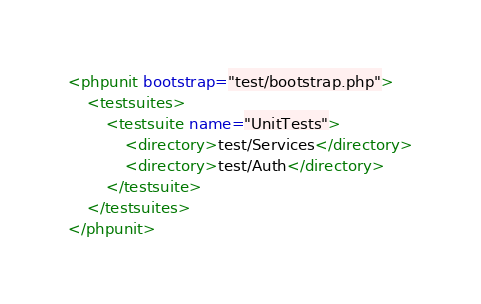<code> <loc_0><loc_0><loc_500><loc_500><_XML_><phpunit bootstrap="test/bootstrap.php">
    <testsuites>
        <testsuite name="UnitTests">
            <directory>test/Services</directory>
            <directory>test/Auth</directory>
        </testsuite>
    </testsuites>
</phpunit></code> 